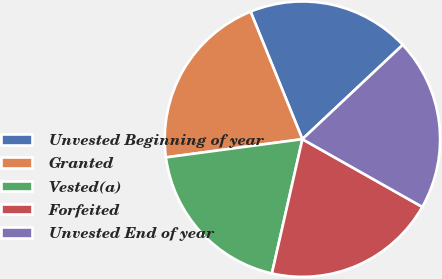<chart> <loc_0><loc_0><loc_500><loc_500><pie_chart><fcel>Unvested Beginning of year<fcel>Granted<fcel>Vested(a)<fcel>Forfeited<fcel>Unvested End of year<nl><fcel>19.14%<fcel>20.97%<fcel>19.33%<fcel>20.37%<fcel>20.19%<nl></chart> 